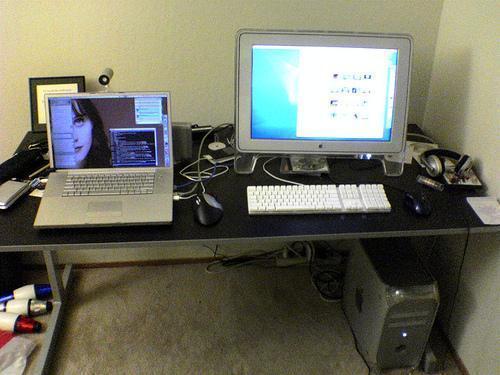How many computer displays are on top of the black desk with two mouses?
Make your selection and explain in format: 'Answer: answer
Rationale: rationale.'
Options: Five, two, four, three. Answer: two.
Rationale: There are 2 displays on the desk. 